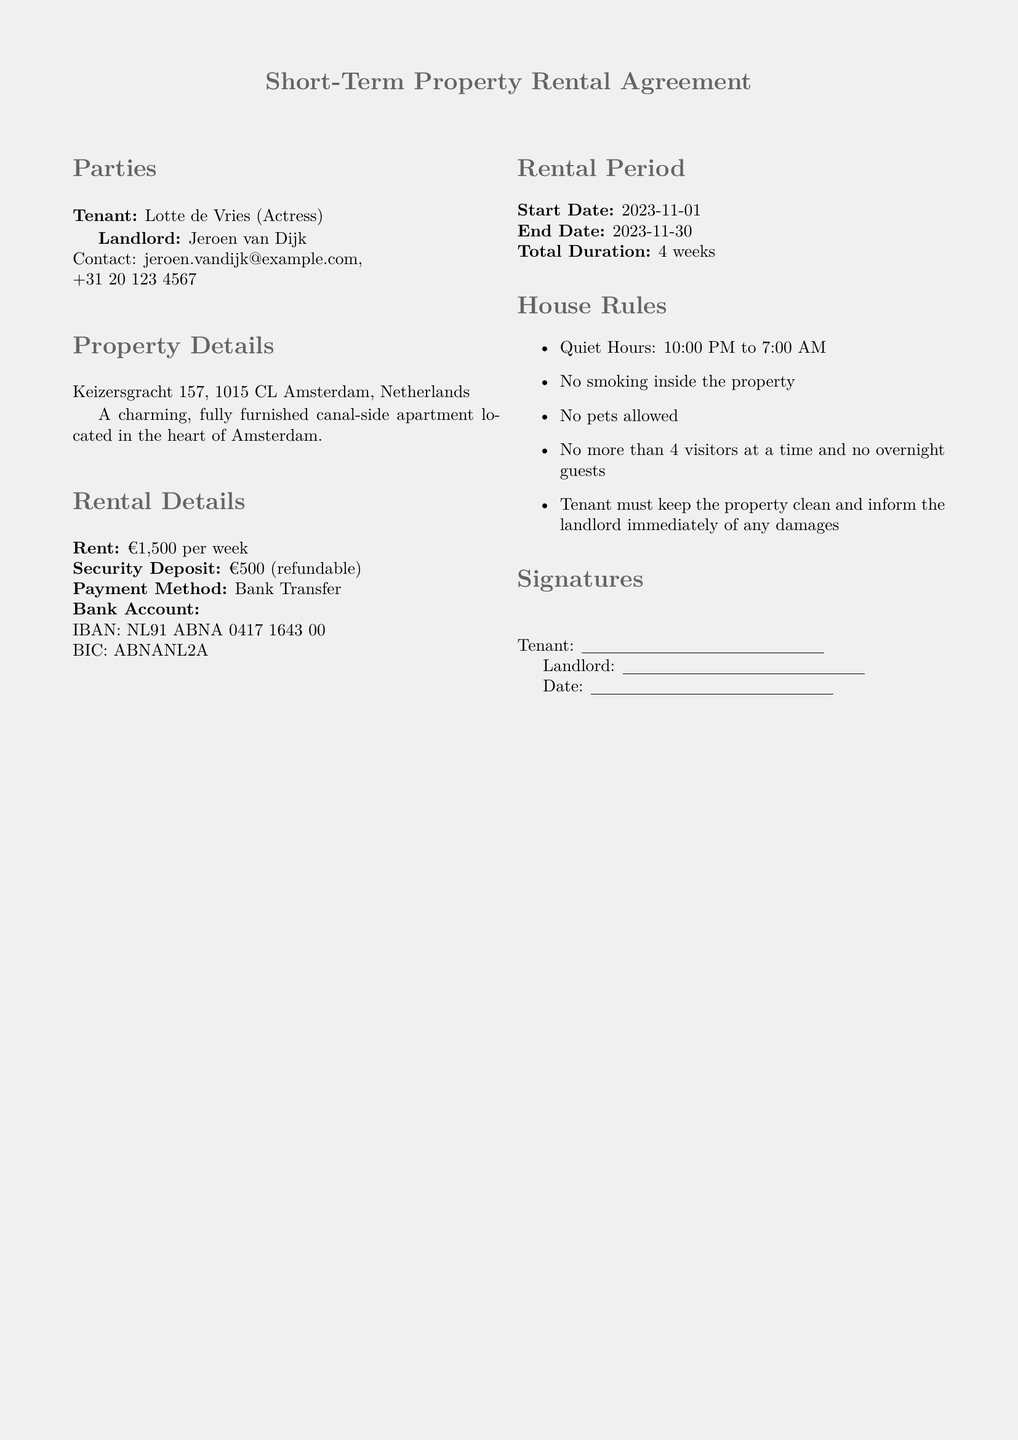What is the rent amount? The rent amount is specified under Rental Details as €1,500 per week.
Answer: €1,500 per week What is the duration of the rental period? The total duration is calculated based on the start and end dates provided in the Rental Period section: from November 1 to November 30.
Answer: 4 weeks Who is the landlord? The landlord's name is listed in the Parties section.
Answer: Jeroen van Dijk What is the security deposit? The amount for the security deposit is mentioned in the Rental Details section as a refundable amount.
Answer: €500 What are the quiet hours? Quiet hours are specified in the House Rules section and indicate when noise must be minimized.
Answer: 10:00 PM to 7:00 AM Are pets allowed in the property? The House Rules section explicitly states the policy regarding pets.
Answer: No What is the payment method for the rent? The payment method is indicated under Rental Details and specifies how the rent should be paid.
Answer: Bank Transfer Where is the property located? The property address is provided in the Property Details section.
Answer: Keizersgracht 157, 1015 CL Amsterdam How many visitors are allowed at a time? This information is stated in the House Rules regarding visitor limitations.
Answer: 4 visitors 